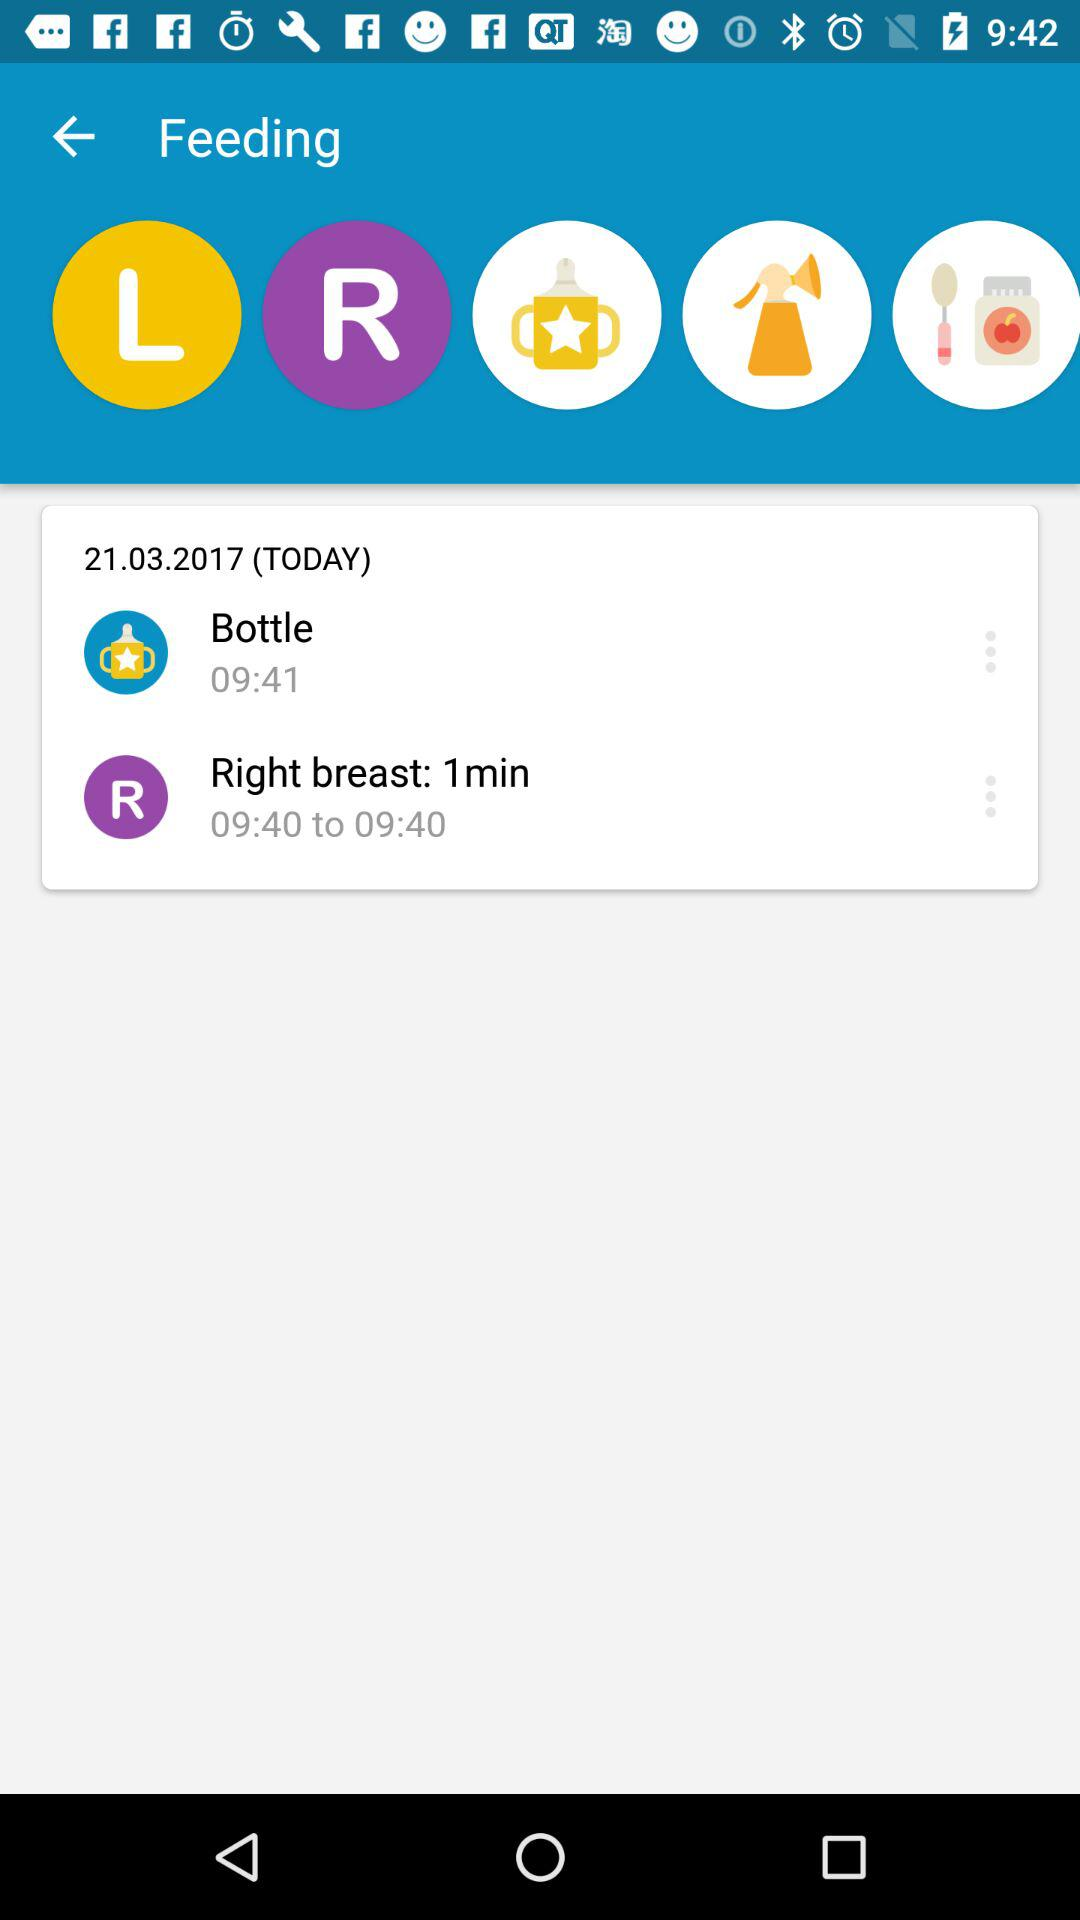What is the feeding date? The feeding date is today, March 21, 2017. 